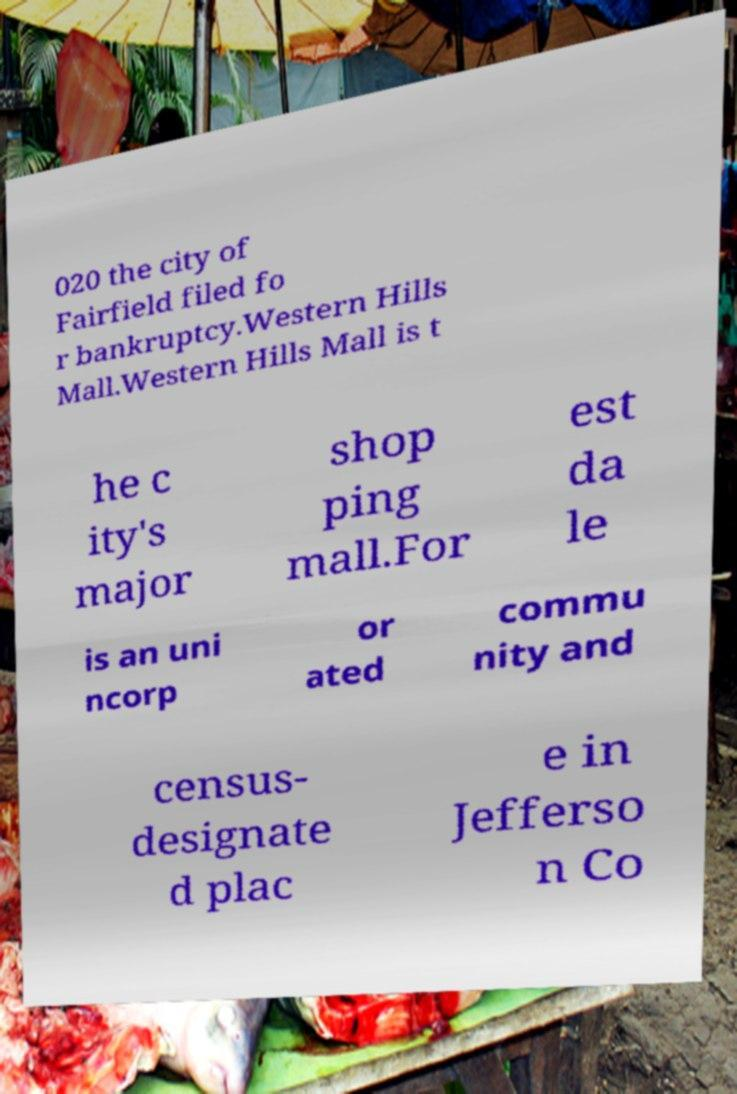Could you extract and type out the text from this image? 020 the city of Fairfield filed fo r bankruptcy.Western Hills Mall.Western Hills Mall is t he c ity's major shop ping mall.For est da le is an uni ncorp or ated commu nity and census- designate d plac e in Jefferso n Co 